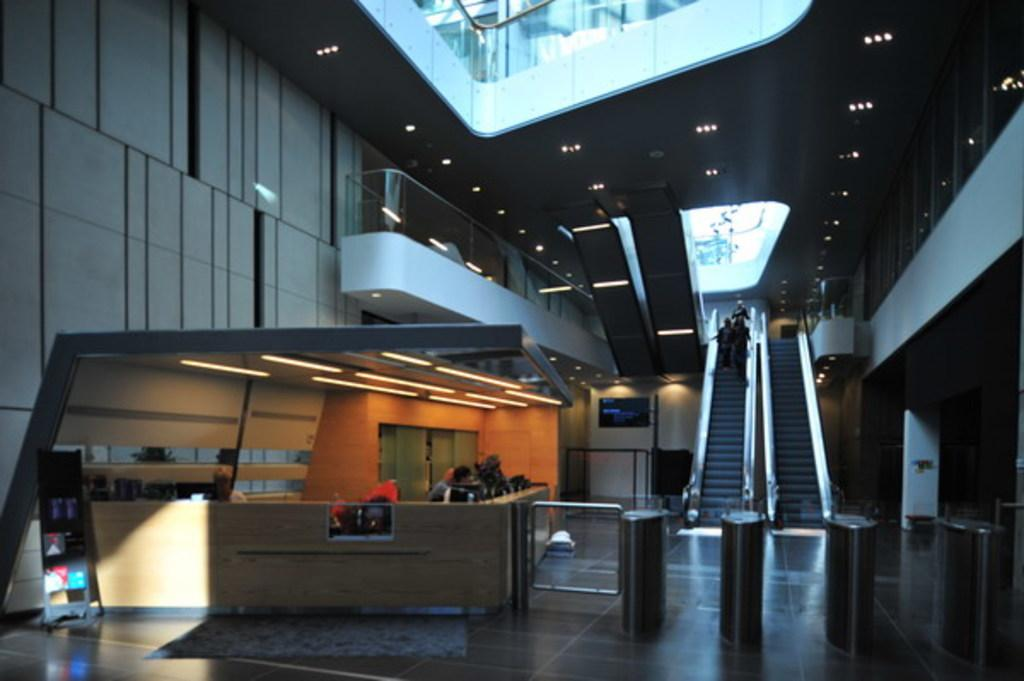What are the people in the image doing? There are people standing on an escalator and people at a reception in the image. What can be seen in the background of the image? The background of the image includes lights. Where is the image taken? The image is an inside view of a building. What type of scale can be seen in the image? There is no scale present in the image. What kind of car is parked near the escalator in the image? There is no car present in the image. 